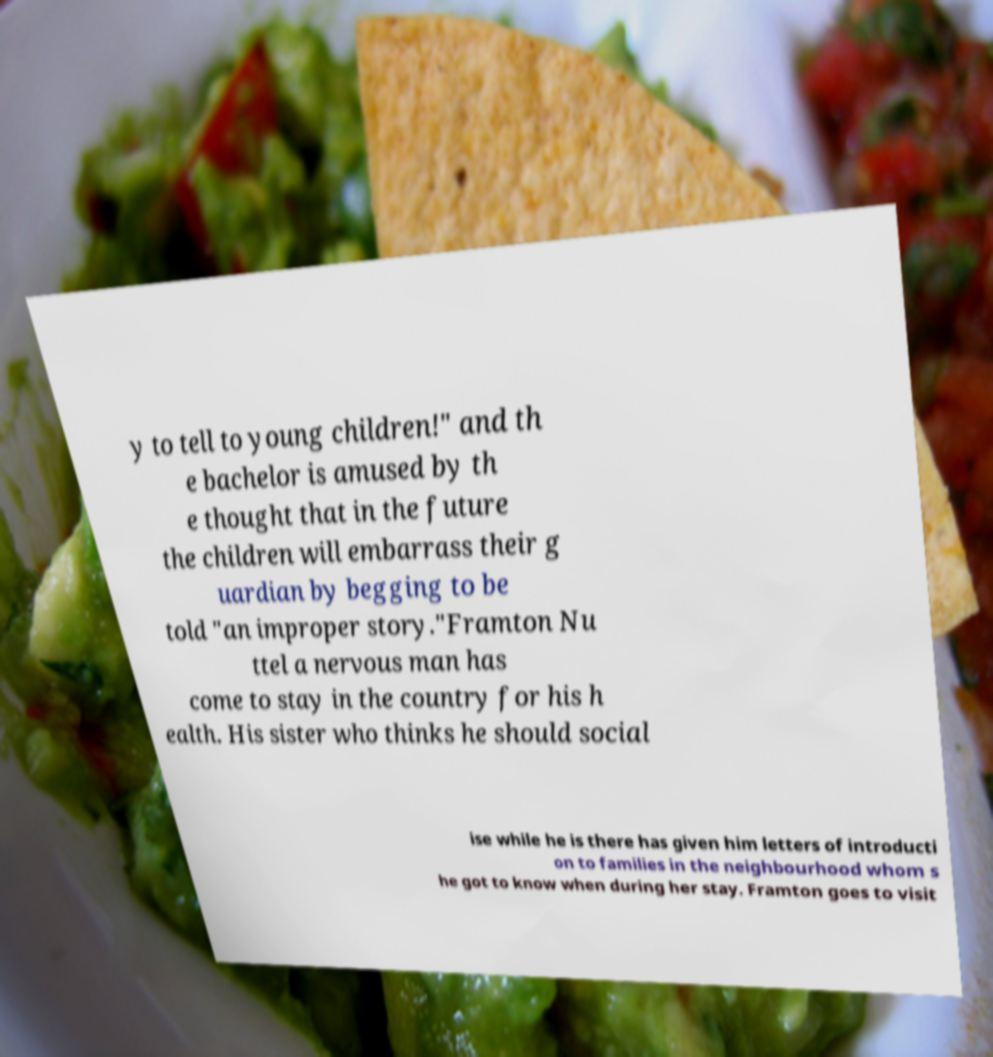Could you assist in decoding the text presented in this image and type it out clearly? y to tell to young children!" and th e bachelor is amused by th e thought that in the future the children will embarrass their g uardian by begging to be told "an improper story."Framton Nu ttel a nervous man has come to stay in the country for his h ealth. His sister who thinks he should social ise while he is there has given him letters of introducti on to families in the neighbourhood whom s he got to know when during her stay. Framton goes to visit 